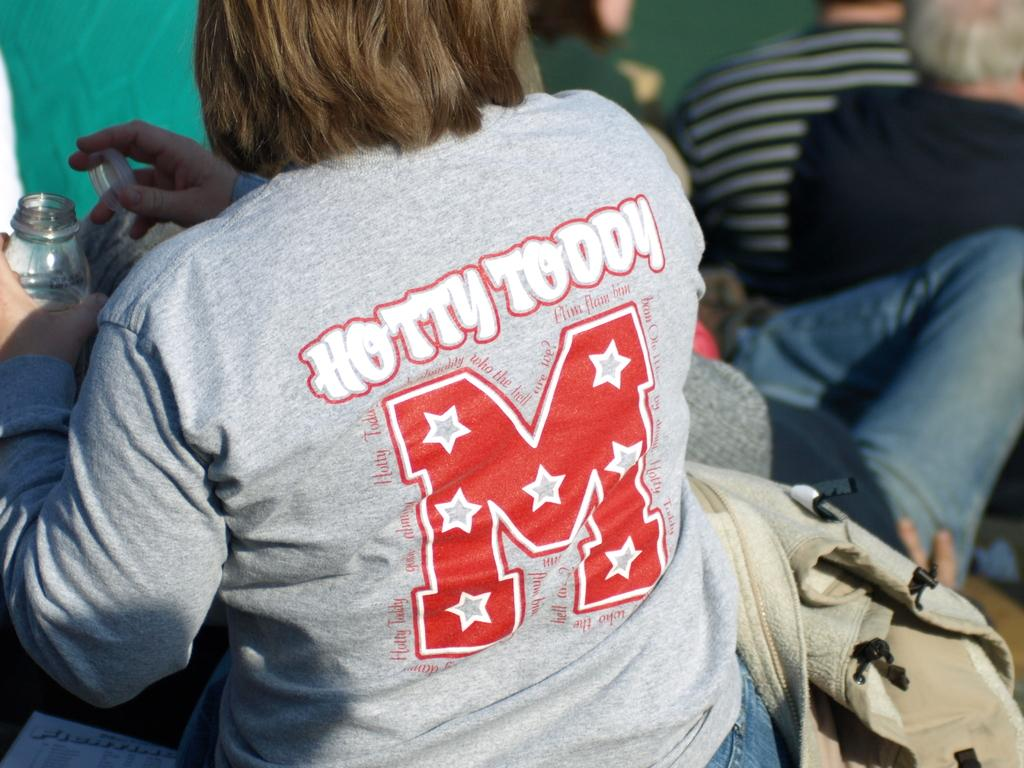Who is the main subject in the picture? There is a woman in the picture. What is the woman wearing? The woman is wearing a t-shirt. What is the woman doing in the image? The woman is sitting. What is the woman holding in her hands? The woman is holding a bottle in her hands. Can you describe the background of the image? There are people in the background of the image. What type of structure can be seen in the background of the image? There is no structure visible in the background of the image; it only shows people. How many feet are visible in the image? There are no feet visible in the image; it only shows a woman sitting and holding a bottle. 